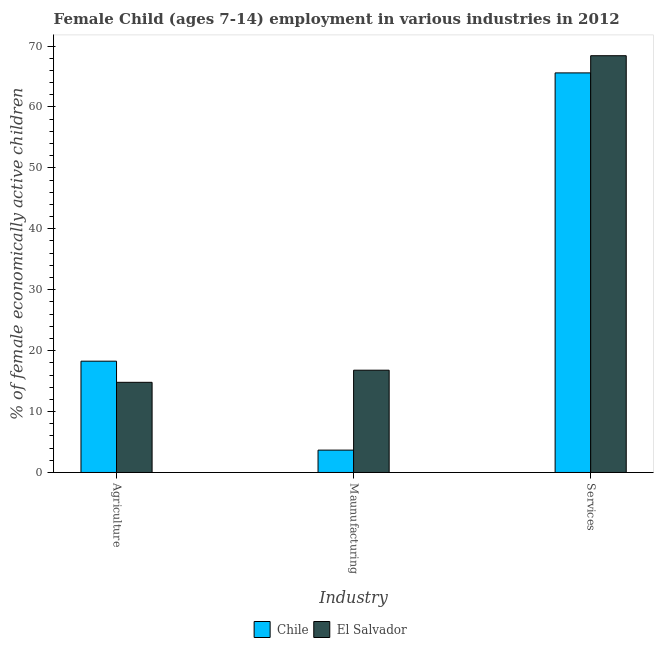How many different coloured bars are there?
Your response must be concise. 2. Are the number of bars per tick equal to the number of legend labels?
Provide a short and direct response. Yes. Are the number of bars on each tick of the X-axis equal?
Offer a terse response. Yes. How many bars are there on the 2nd tick from the left?
Give a very brief answer. 2. How many bars are there on the 3rd tick from the right?
Your answer should be very brief. 2. What is the label of the 1st group of bars from the left?
Provide a succinct answer. Agriculture. What is the percentage of economically active children in agriculture in El Salvador?
Ensure brevity in your answer.  14.8. Across all countries, what is the maximum percentage of economically active children in agriculture?
Your answer should be compact. 18.27. Across all countries, what is the minimum percentage of economically active children in services?
Keep it short and to the point. 65.59. In which country was the percentage of economically active children in services maximum?
Your response must be concise. El Salvador. What is the total percentage of economically active children in manufacturing in the graph?
Keep it short and to the point. 20.46. What is the difference between the percentage of economically active children in manufacturing in Chile and that in El Salvador?
Your response must be concise. -13.12. What is the difference between the percentage of economically active children in services in Chile and the percentage of economically active children in manufacturing in El Salvador?
Your answer should be very brief. 48.8. What is the difference between the percentage of economically active children in manufacturing and percentage of economically active children in services in El Salvador?
Your answer should be very brief. -51.62. In how many countries, is the percentage of economically active children in agriculture greater than 36 %?
Provide a short and direct response. 0. What is the ratio of the percentage of economically active children in services in El Salvador to that in Chile?
Provide a succinct answer. 1.04. Is the percentage of economically active children in services in El Salvador less than that in Chile?
Offer a very short reply. No. What is the difference between the highest and the second highest percentage of economically active children in agriculture?
Provide a succinct answer. 3.47. What is the difference between the highest and the lowest percentage of economically active children in services?
Provide a short and direct response. 2.82. What does the 1st bar from the right in Agriculture represents?
Your answer should be very brief. El Salvador. Is it the case that in every country, the sum of the percentage of economically active children in agriculture and percentage of economically active children in manufacturing is greater than the percentage of economically active children in services?
Provide a succinct answer. No. What is the difference between two consecutive major ticks on the Y-axis?
Ensure brevity in your answer.  10. Does the graph contain any zero values?
Offer a terse response. No. Where does the legend appear in the graph?
Make the answer very short. Bottom center. How are the legend labels stacked?
Ensure brevity in your answer.  Horizontal. What is the title of the graph?
Your answer should be compact. Female Child (ages 7-14) employment in various industries in 2012. Does "Italy" appear as one of the legend labels in the graph?
Your answer should be very brief. No. What is the label or title of the X-axis?
Make the answer very short. Industry. What is the label or title of the Y-axis?
Keep it short and to the point. % of female economically active children. What is the % of female economically active children of Chile in Agriculture?
Your answer should be very brief. 18.27. What is the % of female economically active children in Chile in Maunufacturing?
Ensure brevity in your answer.  3.67. What is the % of female economically active children of El Salvador in Maunufacturing?
Make the answer very short. 16.79. What is the % of female economically active children of Chile in Services?
Provide a short and direct response. 65.59. What is the % of female economically active children in El Salvador in Services?
Your answer should be very brief. 68.41. Across all Industry, what is the maximum % of female economically active children in Chile?
Offer a very short reply. 65.59. Across all Industry, what is the maximum % of female economically active children of El Salvador?
Offer a very short reply. 68.41. Across all Industry, what is the minimum % of female economically active children in Chile?
Keep it short and to the point. 3.67. What is the total % of female economically active children in Chile in the graph?
Your answer should be very brief. 87.53. What is the difference between the % of female economically active children of El Salvador in Agriculture and that in Maunufacturing?
Your answer should be compact. -1.99. What is the difference between the % of female economically active children of Chile in Agriculture and that in Services?
Your response must be concise. -47.32. What is the difference between the % of female economically active children of El Salvador in Agriculture and that in Services?
Ensure brevity in your answer.  -53.61. What is the difference between the % of female economically active children in Chile in Maunufacturing and that in Services?
Offer a very short reply. -61.92. What is the difference between the % of female economically active children in El Salvador in Maunufacturing and that in Services?
Provide a short and direct response. -51.62. What is the difference between the % of female economically active children in Chile in Agriculture and the % of female economically active children in El Salvador in Maunufacturing?
Your answer should be compact. 1.48. What is the difference between the % of female economically active children of Chile in Agriculture and the % of female economically active children of El Salvador in Services?
Give a very brief answer. -50.14. What is the difference between the % of female economically active children of Chile in Maunufacturing and the % of female economically active children of El Salvador in Services?
Keep it short and to the point. -64.74. What is the average % of female economically active children in Chile per Industry?
Make the answer very short. 29.18. What is the average % of female economically active children of El Salvador per Industry?
Keep it short and to the point. 33.33. What is the difference between the % of female economically active children of Chile and % of female economically active children of El Salvador in Agriculture?
Give a very brief answer. 3.47. What is the difference between the % of female economically active children of Chile and % of female economically active children of El Salvador in Maunufacturing?
Provide a short and direct response. -13.12. What is the difference between the % of female economically active children of Chile and % of female economically active children of El Salvador in Services?
Make the answer very short. -2.82. What is the ratio of the % of female economically active children of Chile in Agriculture to that in Maunufacturing?
Keep it short and to the point. 4.98. What is the ratio of the % of female economically active children in El Salvador in Agriculture to that in Maunufacturing?
Offer a very short reply. 0.88. What is the ratio of the % of female economically active children of Chile in Agriculture to that in Services?
Provide a succinct answer. 0.28. What is the ratio of the % of female economically active children in El Salvador in Agriculture to that in Services?
Offer a very short reply. 0.22. What is the ratio of the % of female economically active children of Chile in Maunufacturing to that in Services?
Offer a very short reply. 0.06. What is the ratio of the % of female economically active children in El Salvador in Maunufacturing to that in Services?
Your answer should be very brief. 0.25. What is the difference between the highest and the second highest % of female economically active children of Chile?
Your answer should be compact. 47.32. What is the difference between the highest and the second highest % of female economically active children of El Salvador?
Your answer should be compact. 51.62. What is the difference between the highest and the lowest % of female economically active children of Chile?
Provide a succinct answer. 61.92. What is the difference between the highest and the lowest % of female economically active children in El Salvador?
Your answer should be compact. 53.61. 